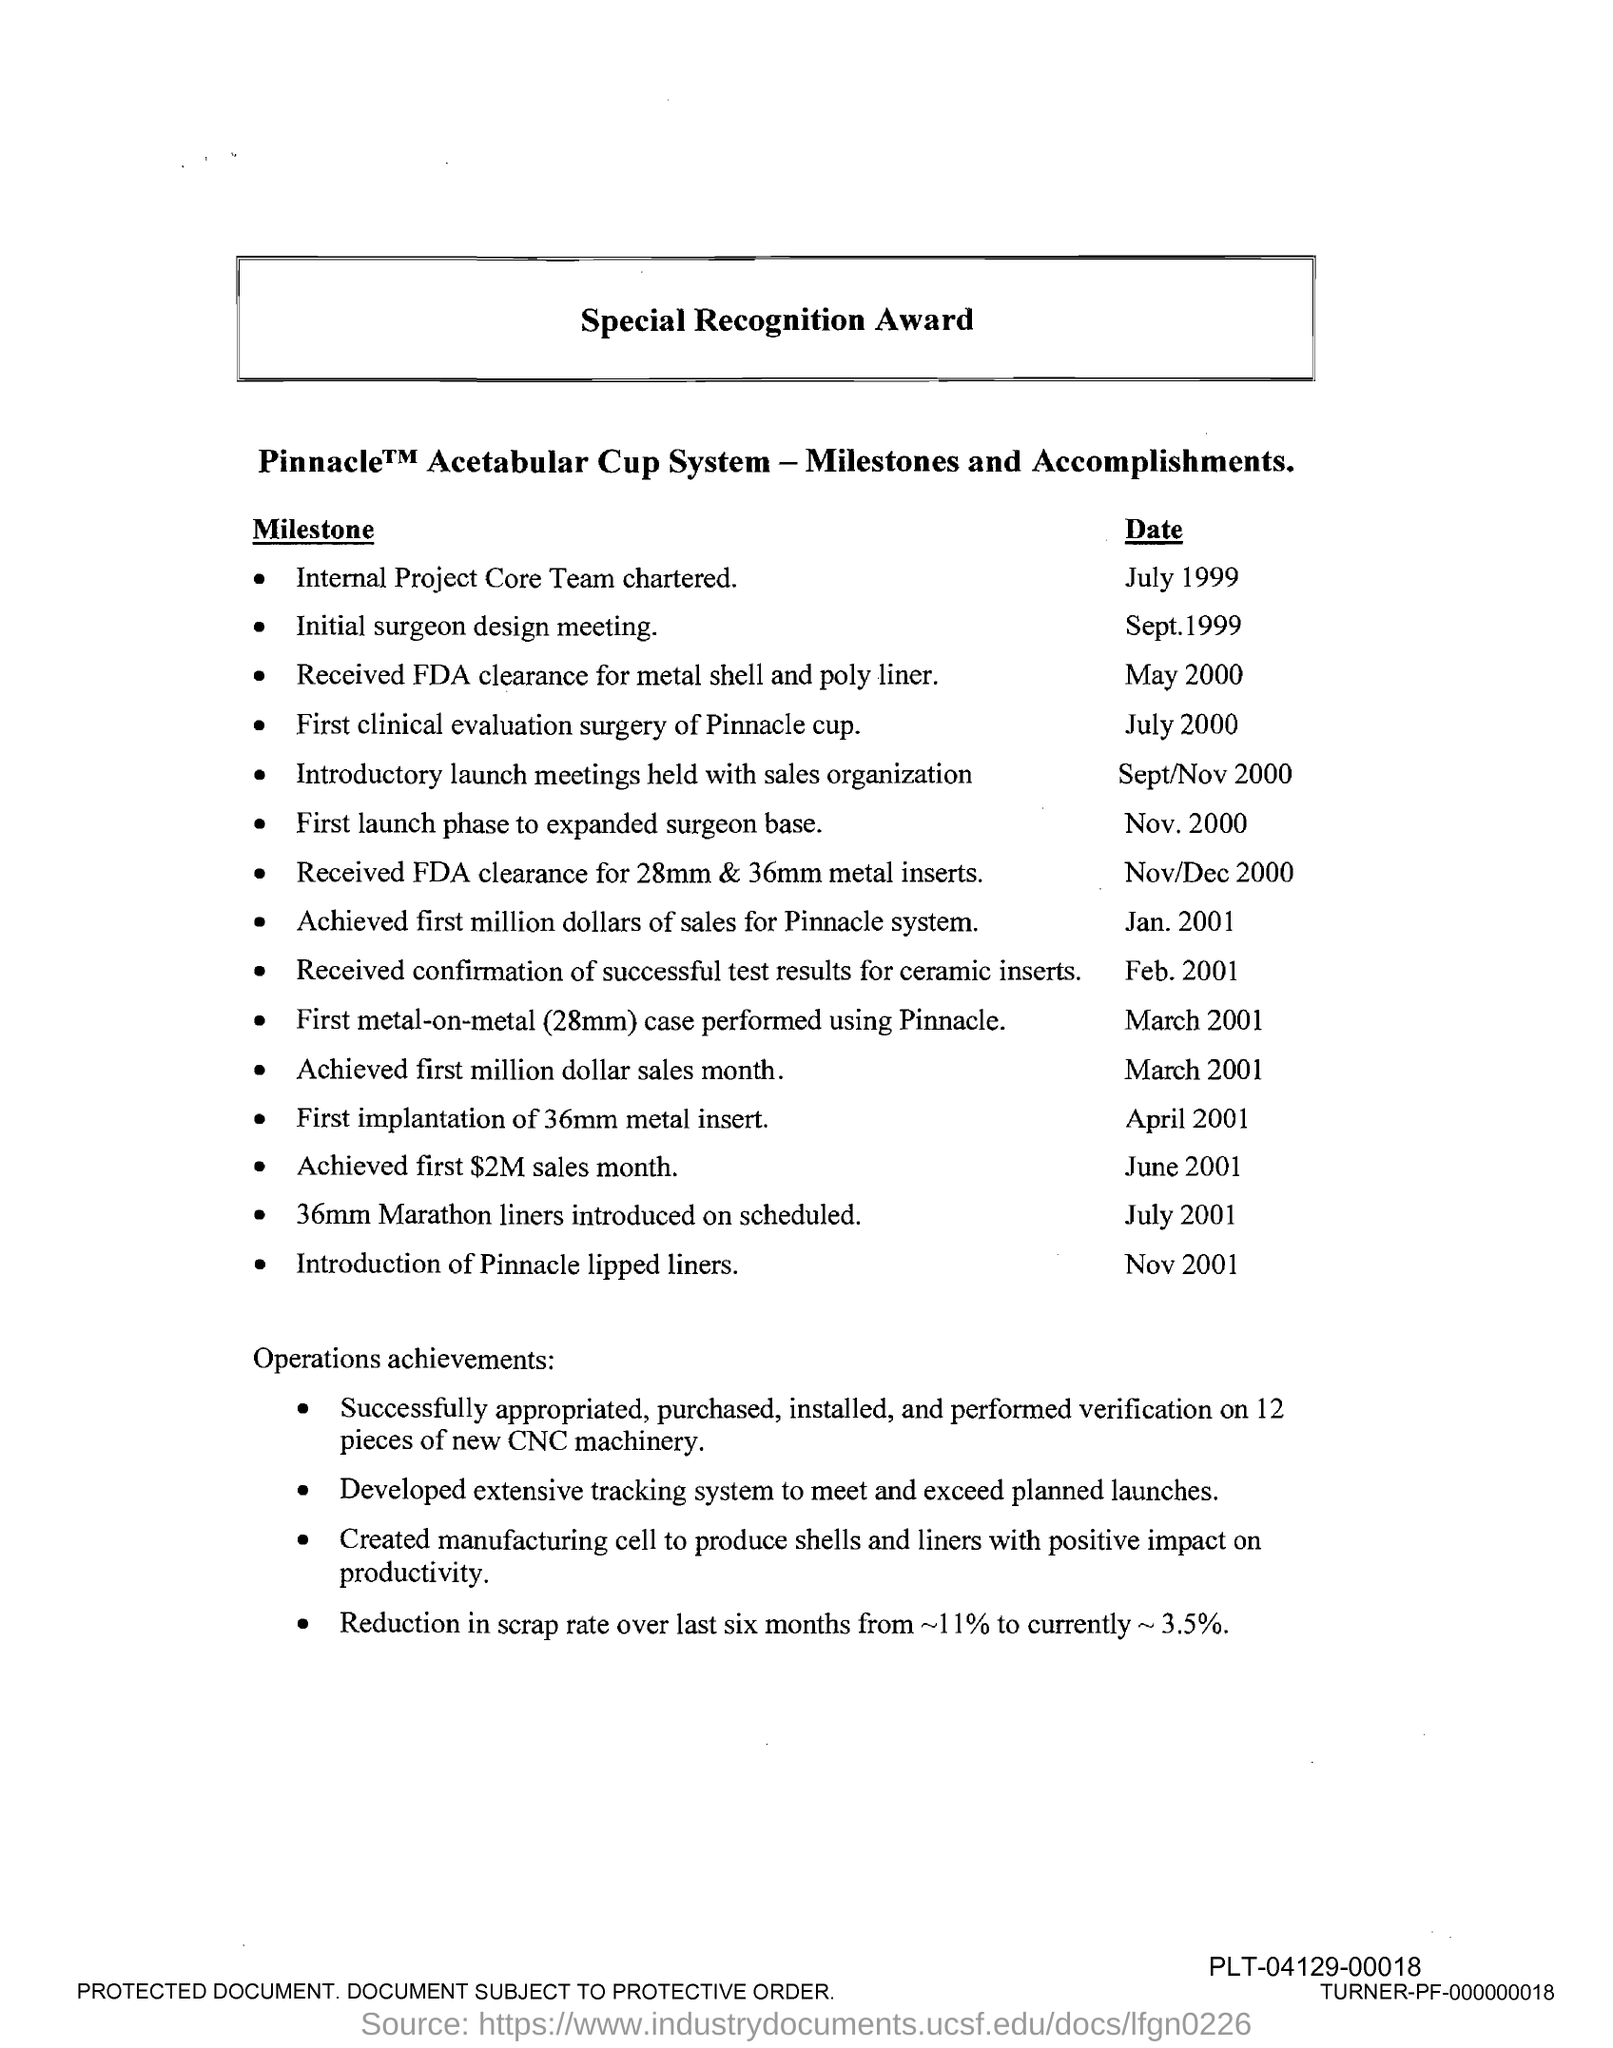What is the title of the document?
Your response must be concise. Special Recognition Award. When was the internal project core team chartered?
Your answer should be very brief. July 1999. When was the pinnacle lipped liners introduced?
Give a very brief answer. Nov 2001. 